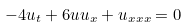<formula> <loc_0><loc_0><loc_500><loc_500>- 4 u _ { t } + 6 u u _ { x } + u _ { x x x } = 0</formula> 